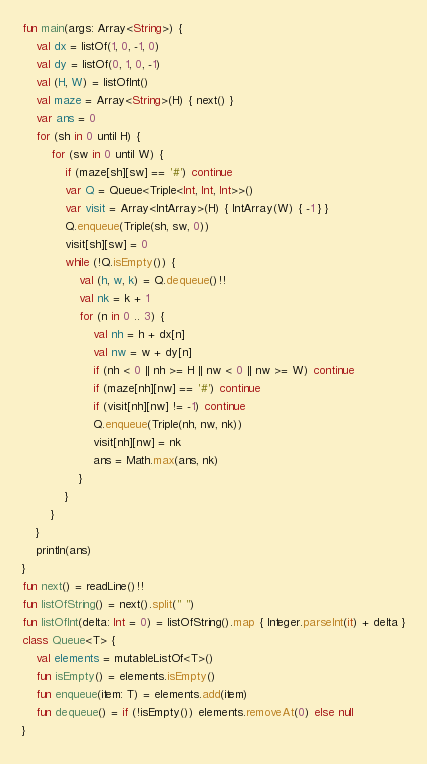<code> <loc_0><loc_0><loc_500><loc_500><_Kotlin_>fun main(args: Array<String>) {
    val dx = listOf(1, 0, -1, 0)
    val dy = listOf(0, 1, 0, -1)
    val (H, W) = listOfInt()
    val maze = Array<String>(H) { next() }
    var ans = 0
    for (sh in 0 until H) {
        for (sw in 0 until W) {
            if (maze[sh][sw] == '#') continue
            var Q = Queue<Triple<Int, Int, Int>>()
            var visit = Array<IntArray>(H) { IntArray(W) { -1 } }
            Q.enqueue(Triple(sh, sw, 0))
            visit[sh][sw] = 0
            while (!Q.isEmpty()) {
                val (h, w, k) = Q.dequeue()!!
                val nk = k + 1
                for (n in 0 .. 3) {
                    val nh = h + dx[n]
                    val nw = w + dy[n]
                    if (nh < 0 || nh >= H || nw < 0 || nw >= W) continue
                    if (maze[nh][nw] == '#') continue
                    if (visit[nh][nw] != -1) continue
                    Q.enqueue(Triple(nh, nw, nk))
                    visit[nh][nw] = nk
                    ans = Math.max(ans, nk)
                }
            }
        }
    }
    println(ans)
}
fun next() = readLine()!!
fun listOfString() = next().split(" ")
fun listOfInt(delta: Int = 0) = listOfString().map { Integer.parseInt(it) + delta }
class Queue<T> {
    val elements = mutableListOf<T>()
    fun isEmpty() = elements.isEmpty()
    fun enqueue(item: T) = elements.add(item)
    fun dequeue() = if (!isEmpty()) elements.removeAt(0) else null
}</code> 